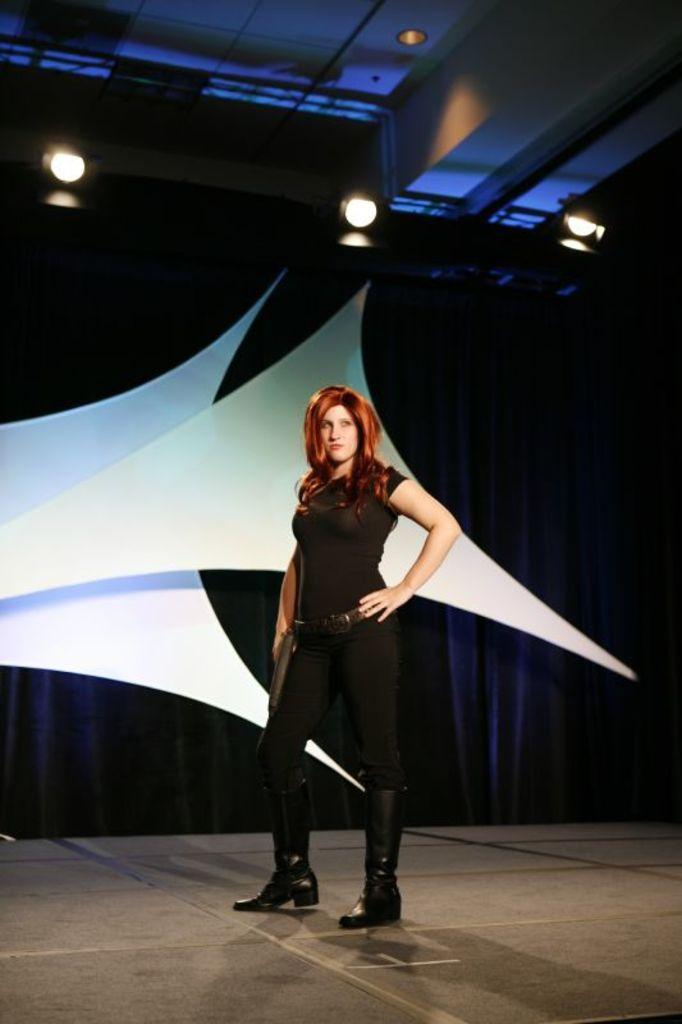What is the main subject of the image? There is a person standing in the image. Can you describe the person's attire? The person is wearing clothes. What can be seen at the top of the image? There are lights at the top of the image. What type of trail can be seen behind the person in the image? There is no trail visible behind the person in the image. What is the person using to pan the area in the image? The person is not using any equipment to pan the area in the image. 